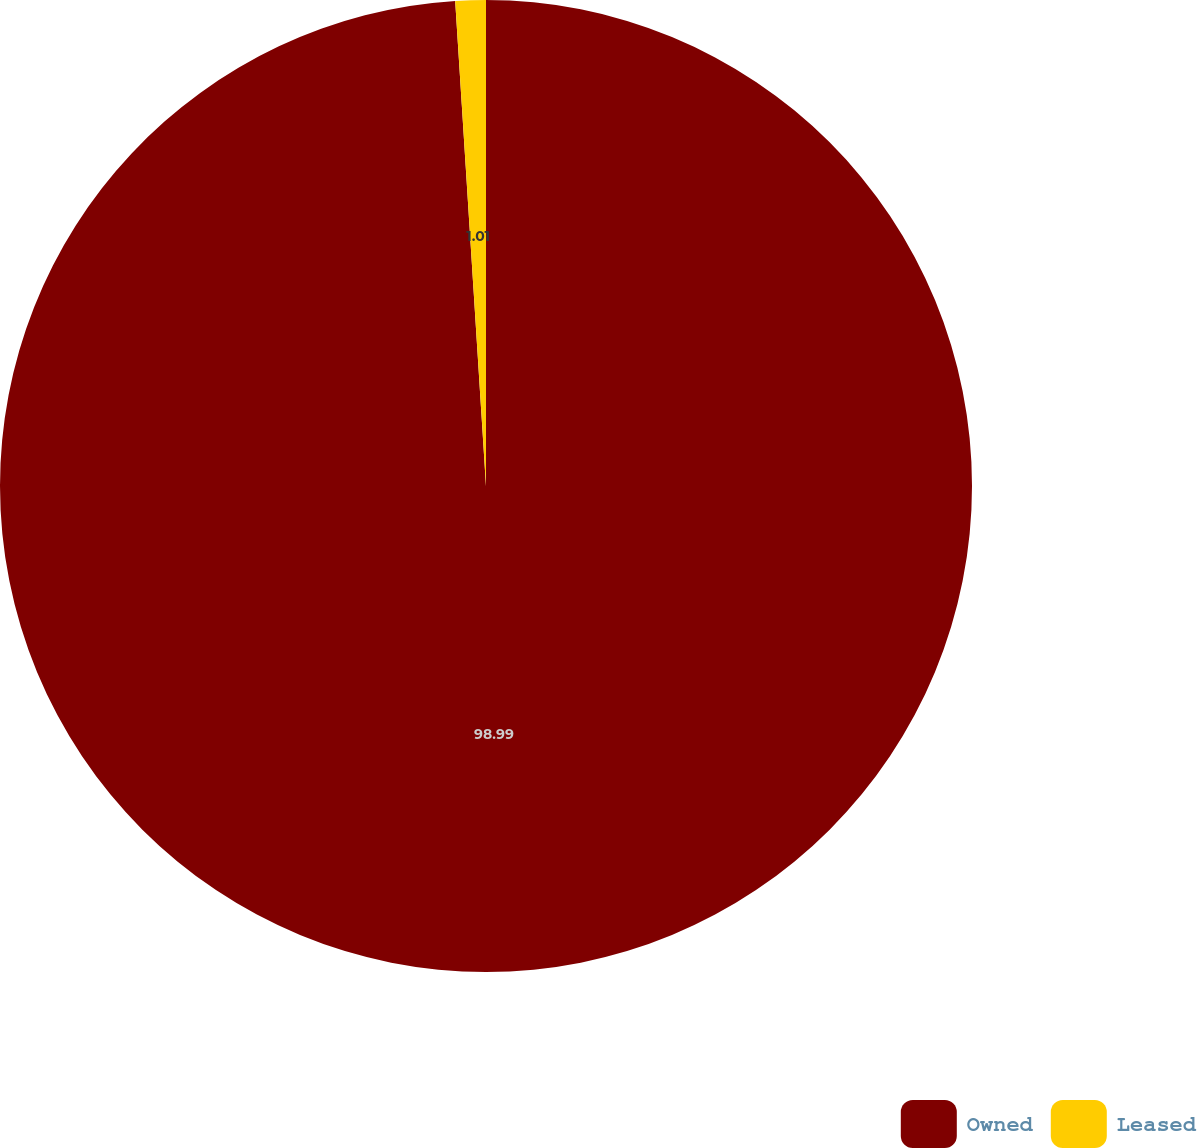<chart> <loc_0><loc_0><loc_500><loc_500><pie_chart><fcel>Owned<fcel>Leased<nl><fcel>98.99%<fcel>1.01%<nl></chart> 